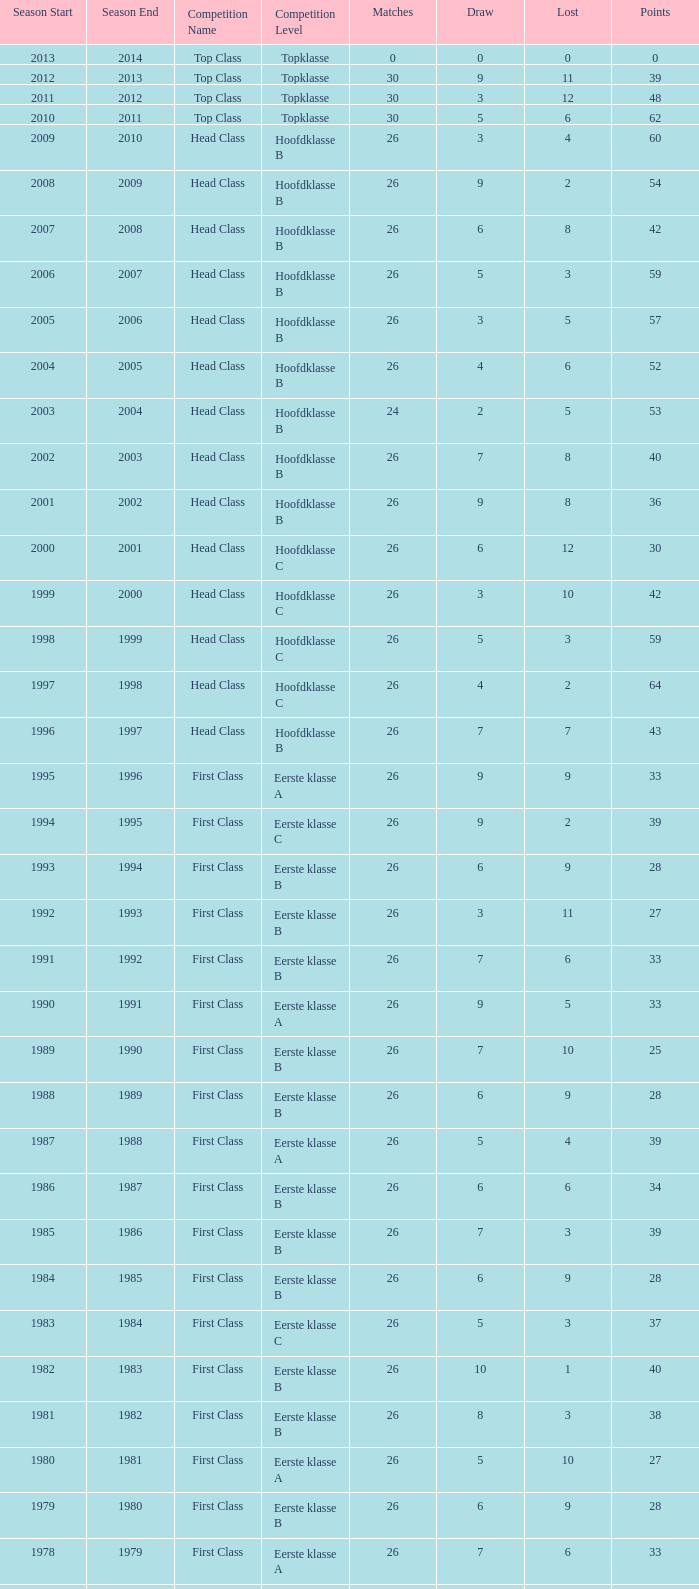Can you give me this table as a dict? {'header': ['Season Start', 'Season End', 'Competition Name', 'Competition Level', 'Matches', 'Draw', 'Lost', 'Points'], 'rows': [['2013', '2014', 'Top Class', 'Topklasse', '0', '0', '0', '0'], ['2012', '2013', 'Top Class', 'Topklasse', '30', '9', '11', '39'], ['2011', '2012', 'Top Class', 'Topklasse', '30', '3', '12', '48'], ['2010', '2011', 'Top Class', 'Topklasse', '30', '5', '6', '62'], ['2009', '2010', 'Head Class', 'Hoofdklasse B', '26', '3', '4', '60'], ['2008', '2009', 'Head Class', 'Hoofdklasse B', '26', '9', '2', '54'], ['2007', '2008', 'Head Class', 'Hoofdklasse B', '26', '6', '8', '42'], ['2006', '2007', 'Head Class', 'Hoofdklasse B', '26', '5', '3', '59'], ['2005', '2006', 'Head Class', 'Hoofdklasse B', '26', '3', '5', '57'], ['2004', '2005', 'Head Class', 'Hoofdklasse B', '26', '4', '6', '52'], ['2003', '2004', 'Head Class', 'Hoofdklasse B', '24', '2', '5', '53'], ['2002', '2003', 'Head Class', 'Hoofdklasse B', '26', '7', '8', '40'], ['2001', '2002', 'Head Class', 'Hoofdklasse B', '26', '9', '8', '36'], ['2000', '2001', 'Head Class', 'Hoofdklasse C', '26', '6', '12', '30'], ['1999', '2000', 'Head Class', 'Hoofdklasse C', '26', '3', '10', '42'], ['1998', '1999', 'Head Class', 'Hoofdklasse C', '26', '5', '3', '59'], ['1997', '1998', 'Head Class', 'Hoofdklasse C', '26', '4', '2', '64'], ['1996', '1997', 'Head Class', 'Hoofdklasse B', '26', '7', '7', '43'], ['1995', '1996', 'First Class', 'Eerste klasse A', '26', '9', '9', '33'], ['1994', '1995', 'First Class', 'Eerste klasse C', '26', '9', '2', '39'], ['1993', '1994', 'First Class', 'Eerste klasse B', '26', '6', '9', '28'], ['1992', '1993', 'First Class', 'Eerste klasse B', '26', '3', '11', '27'], ['1991', '1992', 'First Class', 'Eerste klasse B', '26', '7', '6', '33'], ['1990', '1991', 'First Class', 'Eerste klasse A', '26', '9', '5', '33'], ['1989', '1990', 'First Class', 'Eerste klasse B', '26', '7', '10', '25'], ['1988', '1989', 'First Class', 'Eerste klasse B', '26', '6', '9', '28'], ['1987', '1988', 'First Class', 'Eerste klasse A', '26', '5', '4', '39'], ['1986', '1987', 'First Class', 'Eerste klasse B', '26', '6', '6', '34'], ['1985', '1986', 'First Class', 'Eerste klasse B', '26', '7', '3', '39'], ['1984', '1985', 'First Class', 'Eerste klasse B', '26', '6', '9', '28'], ['1983', '1984', 'First Class', 'Eerste klasse C', '26', '5', '3', '37'], ['1982', '1983', 'First Class', 'Eerste klasse B', '26', '10', '1', '40'], ['1981', '1982', 'First Class', 'Eerste klasse B', '26', '8', '3', '38'], ['1980', '1981', 'First Class', 'Eerste klasse A', '26', '5', '10', '27'], ['1979', '1980', 'First Class', 'Eerste klasse B', '26', '6', '9', '28'], ['1978', '1979', 'First Class', 'Eerste klasse A', '26', '7', '6', '33'], ['1977', '1978', 'First Class', 'Eerste klasse A', '26', '6', '8', '30'], ['1976', '1977', 'First Class', 'Eerste klasse B', '26', '7', '3', '39'], ['1975', '1976', 'First Class', 'Eerste klasse B', '26', '5', '3', '41'], ['1974', '1975', 'First Class', 'Eerste klasse B', '26', '5', '5', '37'], ['1973', '1974', 'First Class', 'Eerste klasse A', '22', '6', '4', '30'], ['1972', '1973', 'First Class', 'Eerste klasse B', '22', '4', '2', '36'], ['1971', '1972', 'First Class', 'Eerste klasse B', '20', '3', '4', '29'], ['1970', '1971', 'First Class', 'Eerste klasse A', '18', '6', '4', '24']]} What competition has a score greater than 30, a draw less than 5, and a loss larger than 10? Top Class (Topklasse). 